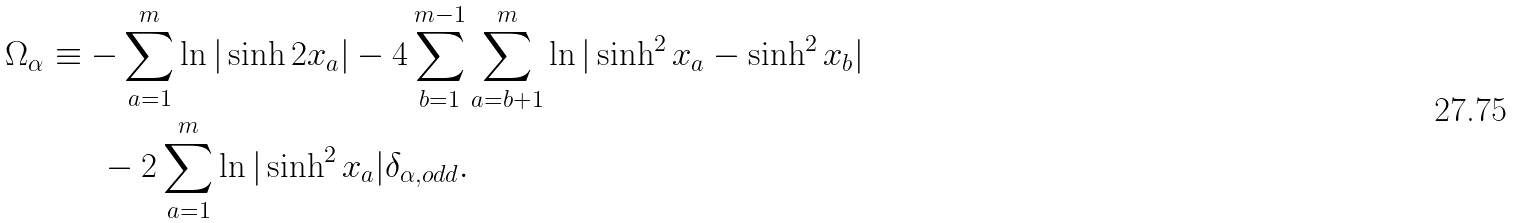Convert formula to latex. <formula><loc_0><loc_0><loc_500><loc_500>\Omega _ { \alpha } & \equiv - \sum _ { a = 1 } ^ { m } \ln | \sinh 2 x _ { a } | - 4 \sum _ { b = 1 } ^ { m - 1 } \sum _ { a = b + 1 } ^ { m } \ln | \sinh ^ { 2 } x _ { a } - \sinh ^ { 2 } x _ { b } | \\ & \quad \ \ - 2 \sum _ { a = 1 } ^ { m } \ln | \sinh ^ { 2 } x _ { a } | \delta _ { \alpha , o d d } .</formula> 